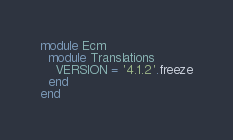Convert code to text. <code><loc_0><loc_0><loc_500><loc_500><_Ruby_>module Ecm
  module Translations
    VERSION = '4.1.2'.freeze
  end
end
</code> 